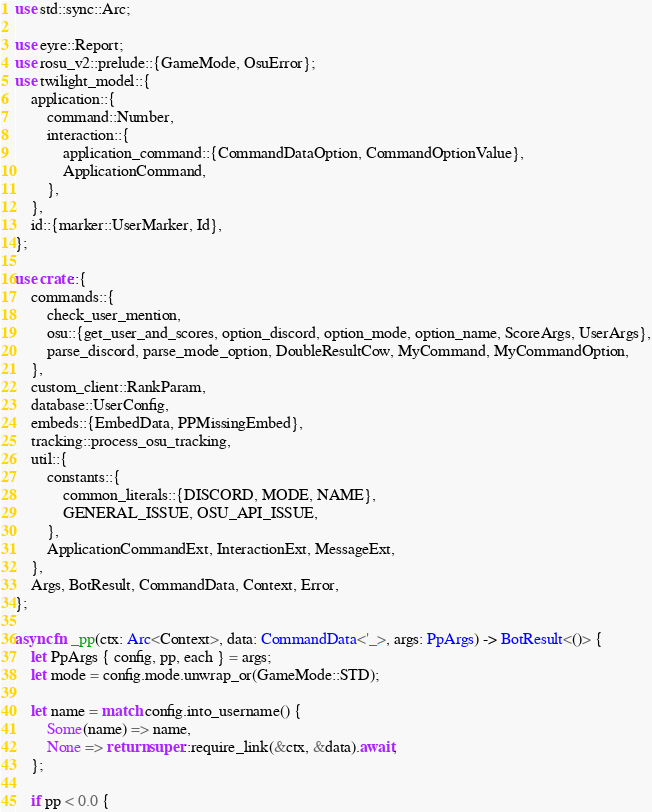<code> <loc_0><loc_0><loc_500><loc_500><_Rust_>use std::sync::Arc;

use eyre::Report;
use rosu_v2::prelude::{GameMode, OsuError};
use twilight_model::{
    application::{
        command::Number,
        interaction::{
            application_command::{CommandDataOption, CommandOptionValue},
            ApplicationCommand,
        },
    },
    id::{marker::UserMarker, Id},
};

use crate::{
    commands::{
        check_user_mention,
        osu::{get_user_and_scores, option_discord, option_mode, option_name, ScoreArgs, UserArgs},
        parse_discord, parse_mode_option, DoubleResultCow, MyCommand, MyCommandOption,
    },
    custom_client::RankParam,
    database::UserConfig,
    embeds::{EmbedData, PPMissingEmbed},
    tracking::process_osu_tracking,
    util::{
        constants::{
            common_literals::{DISCORD, MODE, NAME},
            GENERAL_ISSUE, OSU_API_ISSUE,
        },
        ApplicationCommandExt, InteractionExt, MessageExt,
    },
    Args, BotResult, CommandData, Context, Error,
};

async fn _pp(ctx: Arc<Context>, data: CommandData<'_>, args: PpArgs) -> BotResult<()> {
    let PpArgs { config, pp, each } = args;
    let mode = config.mode.unwrap_or(GameMode::STD);

    let name = match config.into_username() {
        Some(name) => name,
        None => return super::require_link(&ctx, &data).await,
    };

    if pp < 0.0 {</code> 